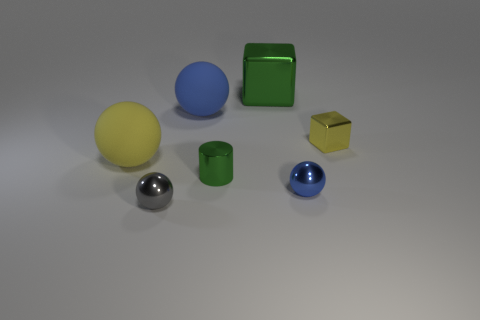Add 1 purple objects. How many objects exist? 8 Subtract all cylinders. How many objects are left? 6 Add 5 large green rubber objects. How many large green rubber objects exist? 5 Subtract 0 cyan cylinders. How many objects are left? 7 Subtract all tiny cylinders. Subtract all small green shiny cylinders. How many objects are left? 5 Add 4 blocks. How many blocks are left? 6 